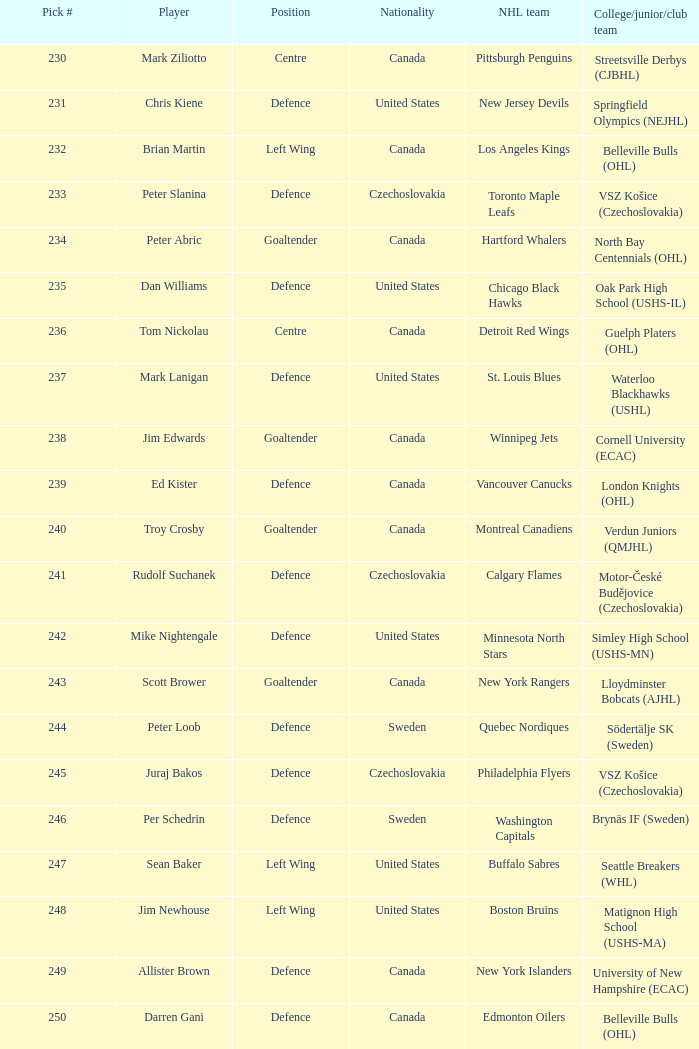What was the draft selection number for the new jersey devils? 231.0. 